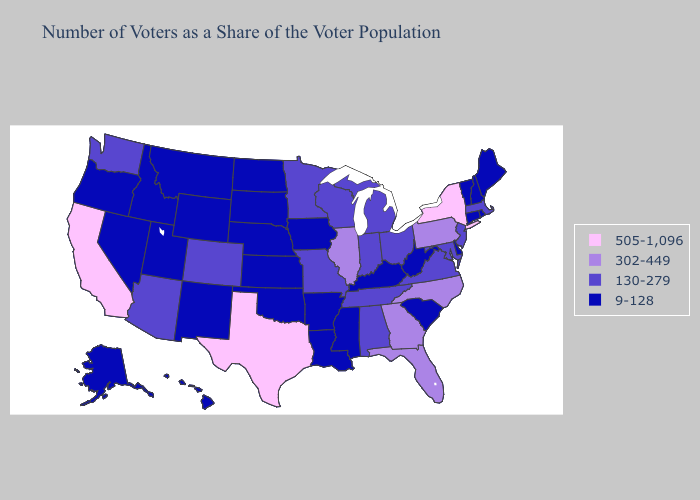Name the states that have a value in the range 505-1,096?
Answer briefly. California, New York, Texas. What is the lowest value in the Northeast?
Give a very brief answer. 9-128. What is the lowest value in states that border Mississippi?
Concise answer only. 9-128. Does Hawaii have a lower value than Pennsylvania?
Answer briefly. Yes. What is the highest value in the USA?
Answer briefly. 505-1,096. Name the states that have a value in the range 505-1,096?
Be succinct. California, New York, Texas. Which states have the highest value in the USA?
Be succinct. California, New York, Texas. Does Vermont have the lowest value in the Northeast?
Give a very brief answer. Yes. What is the value of Louisiana?
Concise answer only. 9-128. What is the value of Kentucky?
Answer briefly. 9-128. What is the highest value in states that border Idaho?
Concise answer only. 130-279. What is the value of Oklahoma?
Be succinct. 9-128. Among the states that border Indiana , does Illinois have the highest value?
Short answer required. Yes. What is the highest value in states that border South Dakota?
Write a very short answer. 130-279. 